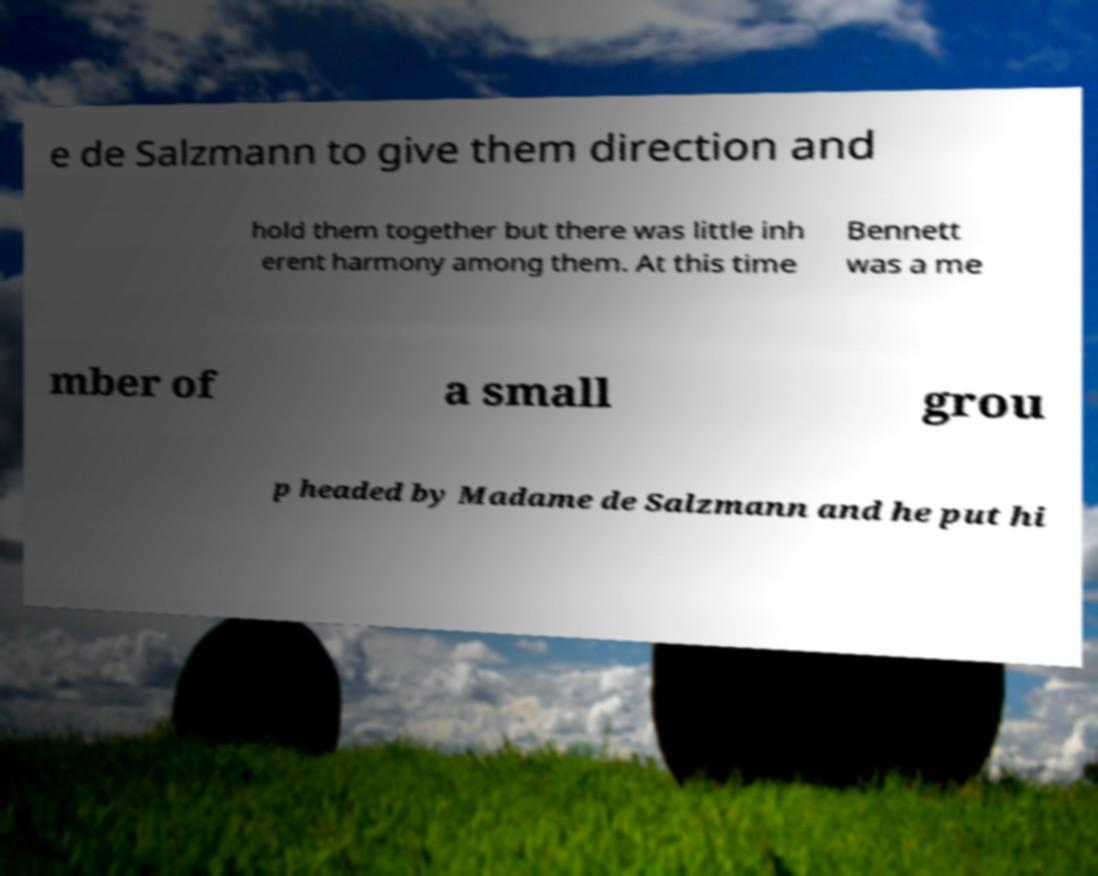There's text embedded in this image that I need extracted. Can you transcribe it verbatim? e de Salzmann to give them direction and hold them together but there was little inh erent harmony among them. At this time Bennett was a me mber of a small grou p headed by Madame de Salzmann and he put hi 